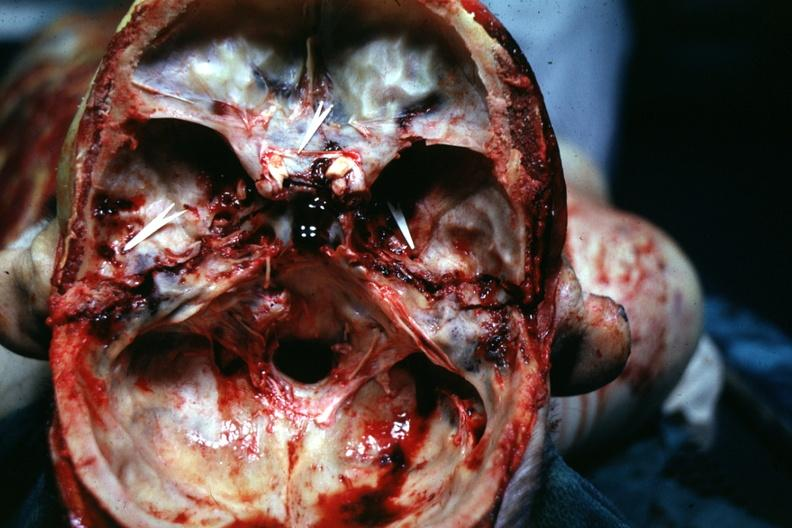what is present?
Answer the question using a single word or phrase. Bone, calvarium 